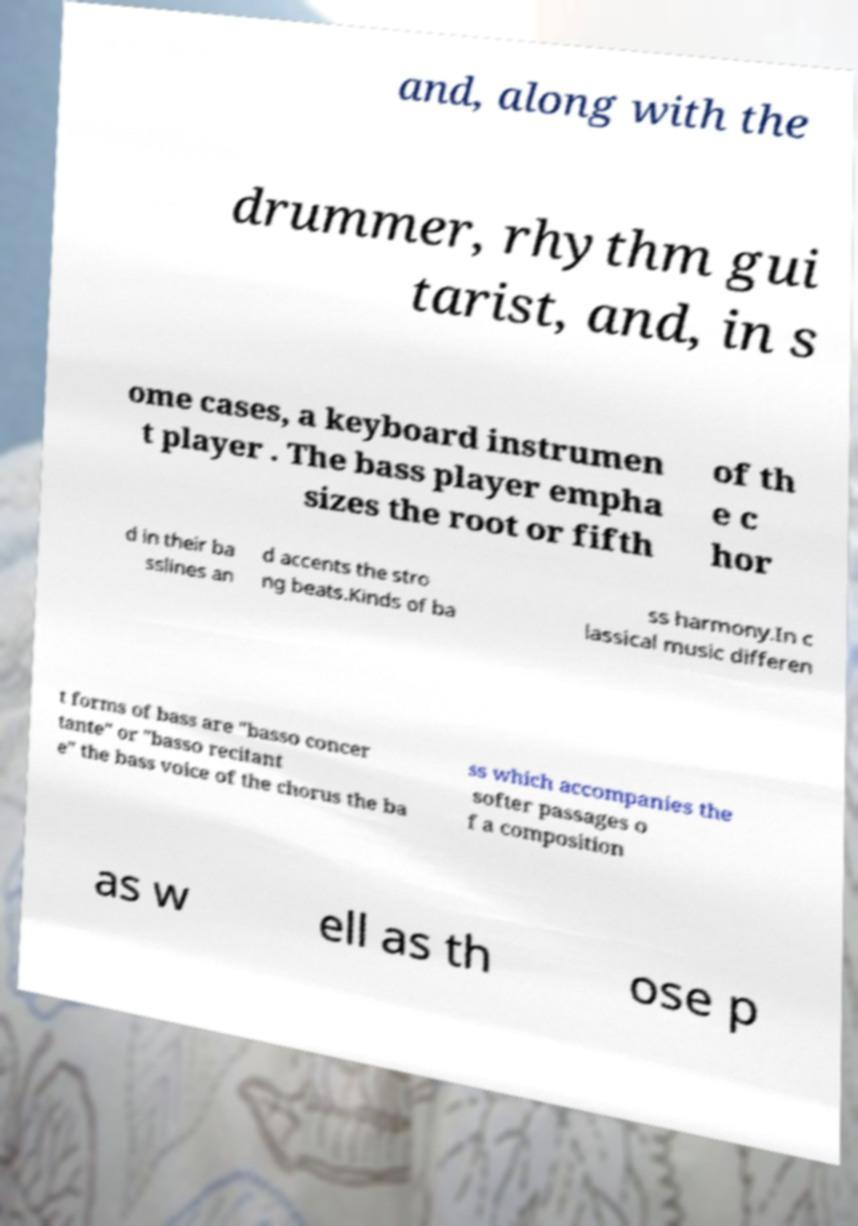Can you accurately transcribe the text from the provided image for me? and, along with the drummer, rhythm gui tarist, and, in s ome cases, a keyboard instrumen t player . The bass player empha sizes the root or fifth of th e c hor d in their ba sslines an d accents the stro ng beats.Kinds of ba ss harmony.In c lassical music differen t forms of bass are "basso concer tante" or "basso recitant e" the bass voice of the chorus the ba ss which accompanies the softer passages o f a composition as w ell as th ose p 